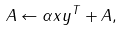Convert formula to latex. <formula><loc_0><loc_0><loc_500><loc_500>A \leftarrow \alpha x y ^ { T } + A ,</formula> 